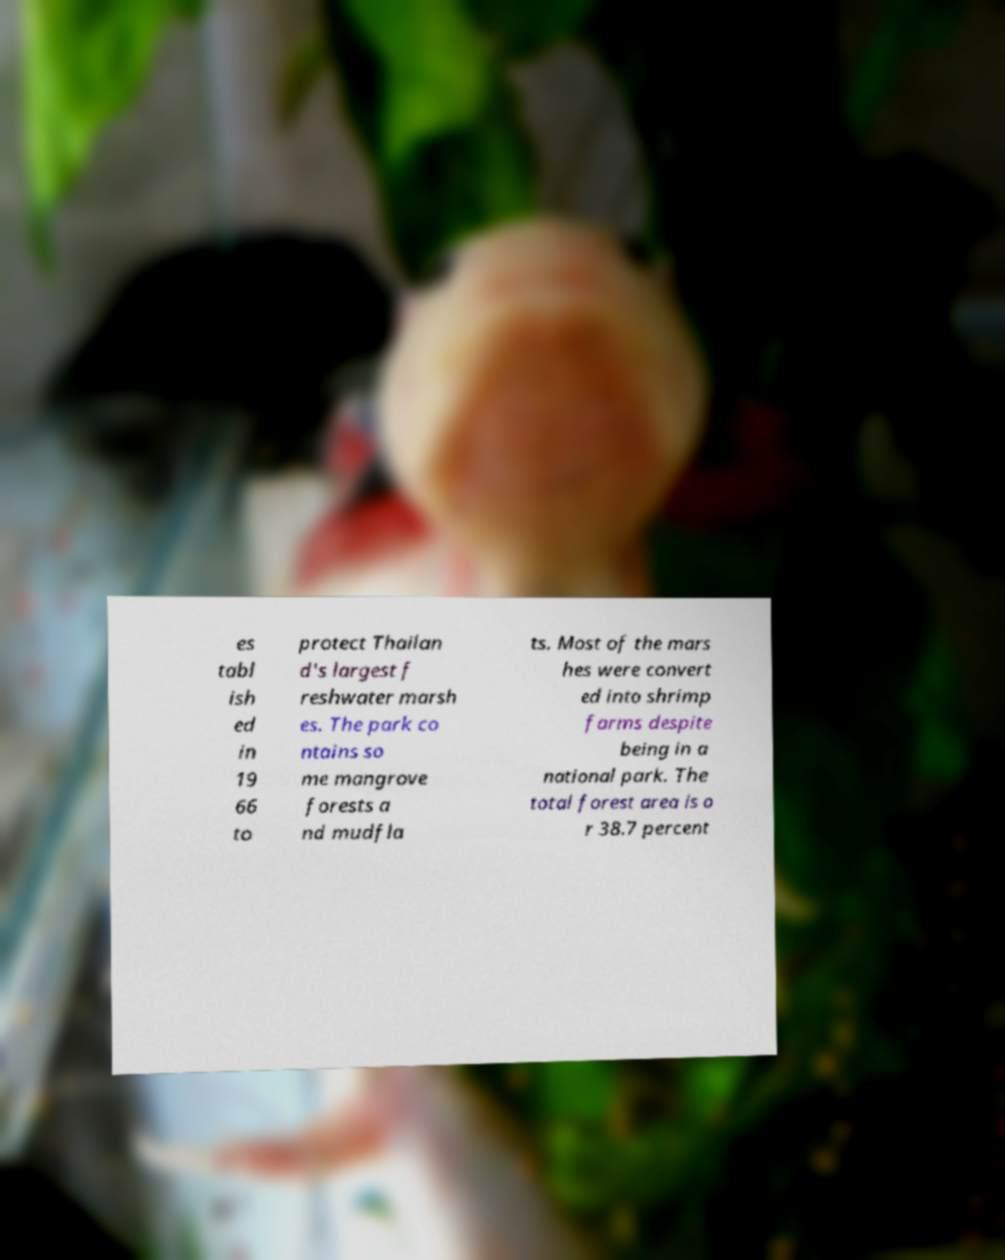There's text embedded in this image that I need extracted. Can you transcribe it verbatim? es tabl ish ed in 19 66 to protect Thailan d's largest f reshwater marsh es. The park co ntains so me mangrove forests a nd mudfla ts. Most of the mars hes were convert ed into shrimp farms despite being in a national park. The total forest area is o r 38.7 percent 